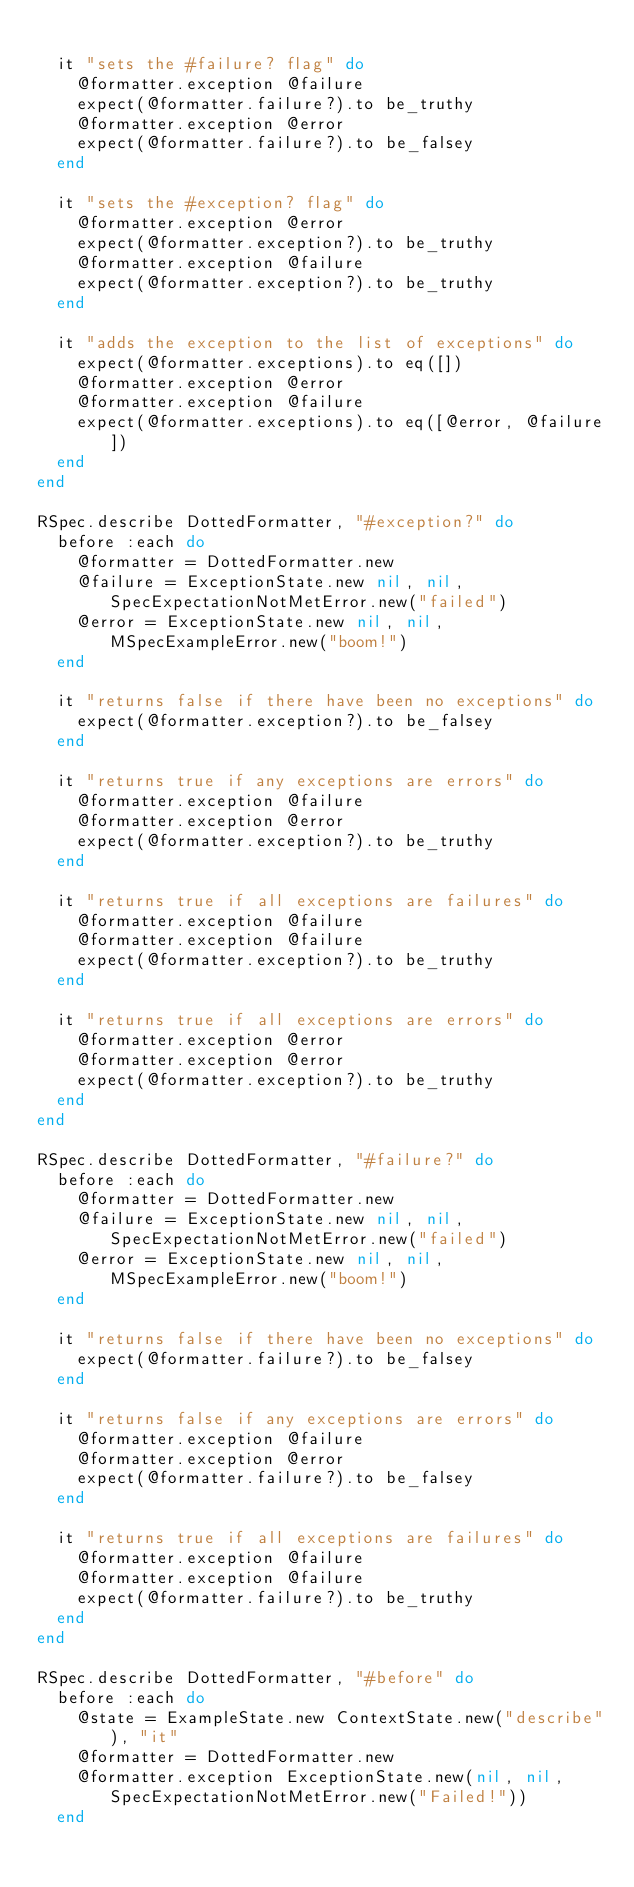<code> <loc_0><loc_0><loc_500><loc_500><_Ruby_>
  it "sets the #failure? flag" do
    @formatter.exception @failure
    expect(@formatter.failure?).to be_truthy
    @formatter.exception @error
    expect(@formatter.failure?).to be_falsey
  end

  it "sets the #exception? flag" do
    @formatter.exception @error
    expect(@formatter.exception?).to be_truthy
    @formatter.exception @failure
    expect(@formatter.exception?).to be_truthy
  end

  it "adds the exception to the list of exceptions" do
    expect(@formatter.exceptions).to eq([])
    @formatter.exception @error
    @formatter.exception @failure
    expect(@formatter.exceptions).to eq([@error, @failure])
  end
end

RSpec.describe DottedFormatter, "#exception?" do
  before :each do
    @formatter = DottedFormatter.new
    @failure = ExceptionState.new nil, nil, SpecExpectationNotMetError.new("failed")
    @error = ExceptionState.new nil, nil, MSpecExampleError.new("boom!")
  end

  it "returns false if there have been no exceptions" do
    expect(@formatter.exception?).to be_falsey
  end

  it "returns true if any exceptions are errors" do
    @formatter.exception @failure
    @formatter.exception @error
    expect(@formatter.exception?).to be_truthy
  end

  it "returns true if all exceptions are failures" do
    @formatter.exception @failure
    @formatter.exception @failure
    expect(@formatter.exception?).to be_truthy
  end

  it "returns true if all exceptions are errors" do
    @formatter.exception @error
    @formatter.exception @error
    expect(@formatter.exception?).to be_truthy
  end
end

RSpec.describe DottedFormatter, "#failure?" do
  before :each do
    @formatter = DottedFormatter.new
    @failure = ExceptionState.new nil, nil, SpecExpectationNotMetError.new("failed")
    @error = ExceptionState.new nil, nil, MSpecExampleError.new("boom!")
  end

  it "returns false if there have been no exceptions" do
    expect(@formatter.failure?).to be_falsey
  end

  it "returns false if any exceptions are errors" do
    @formatter.exception @failure
    @formatter.exception @error
    expect(@formatter.failure?).to be_falsey
  end

  it "returns true if all exceptions are failures" do
    @formatter.exception @failure
    @formatter.exception @failure
    expect(@formatter.failure?).to be_truthy
  end
end

RSpec.describe DottedFormatter, "#before" do
  before :each do
    @state = ExampleState.new ContextState.new("describe"), "it"
    @formatter = DottedFormatter.new
    @formatter.exception ExceptionState.new(nil, nil, SpecExpectationNotMetError.new("Failed!"))
  end
</code> 